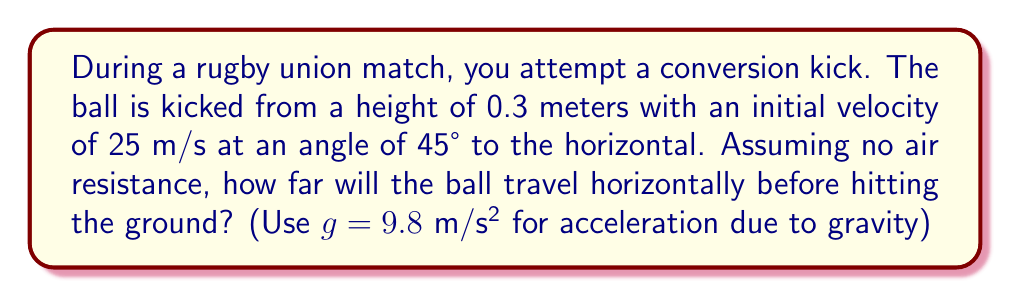Can you answer this question? Let's approach this step-by-step using projectile motion equations:

1) First, we need to decompose the initial velocity into horizontal and vertical components:

   $v_{0x} = v_0 \cos \theta = 25 \cos 45° = 25 \cdot \frac{\sqrt{2}}{2} \approx 17.68$ m/s
   $v_{0y} = v_0 \sin \theta = 25 \sin 45° = 25 \cdot \frac{\sqrt{2}}{2} \approx 17.68$ m/s

2) The time of flight can be calculated using the equation:
   $$y = y_0 + v_{0y}t - \frac{1}{2}gt^2$$

   Where $y = 0$ (ground level), $y_0 = 0.3$ m (initial height), and $g = 9.8$ m/s²

3) Substituting these values:
   $$0 = 0.3 + 17.68t - 4.9t^2$$

4) Rearranging:
   $$4.9t^2 - 17.68t - 0.3 = 0$$

5) This is a quadratic equation. We can solve it using the quadratic formula:
   $$t = \frac{-b \pm \sqrt{b^2 - 4ac}}{2a}$$

   Where $a = 4.9$, $b = -17.68$, and $c = -0.3$

6) Solving this gives us two solutions: $t \approx 3.67$ s or $t \approx -0.0167$ s

   We take the positive solution as time can't be negative.

7) Now that we know the time of flight, we can calculate the horizontal distance using:
   $$x = v_{0x}t$$

8) Substituting our values:
   $$x = 17.68 \cdot 3.67 \approx 64.89$$ meters

Therefore, the ball will travel approximately 64.89 meters horizontally before hitting the ground.
Answer: 64.89 meters 